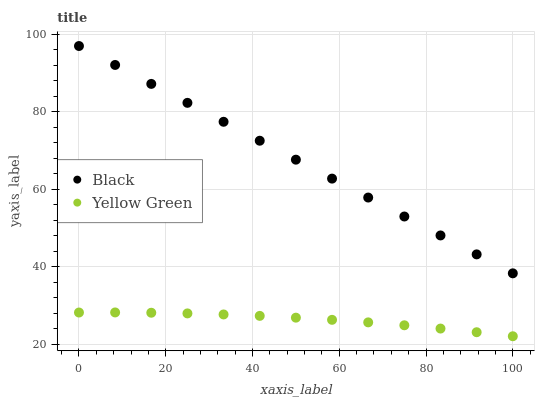Does Yellow Green have the minimum area under the curve?
Answer yes or no. Yes. Does Black have the maximum area under the curve?
Answer yes or no. Yes. Does Yellow Green have the maximum area under the curve?
Answer yes or no. No. Is Black the smoothest?
Answer yes or no. Yes. Is Yellow Green the roughest?
Answer yes or no. Yes. Is Yellow Green the smoothest?
Answer yes or no. No. Does Yellow Green have the lowest value?
Answer yes or no. Yes. Does Black have the highest value?
Answer yes or no. Yes. Does Yellow Green have the highest value?
Answer yes or no. No. Is Yellow Green less than Black?
Answer yes or no. Yes. Is Black greater than Yellow Green?
Answer yes or no. Yes. Does Yellow Green intersect Black?
Answer yes or no. No. 